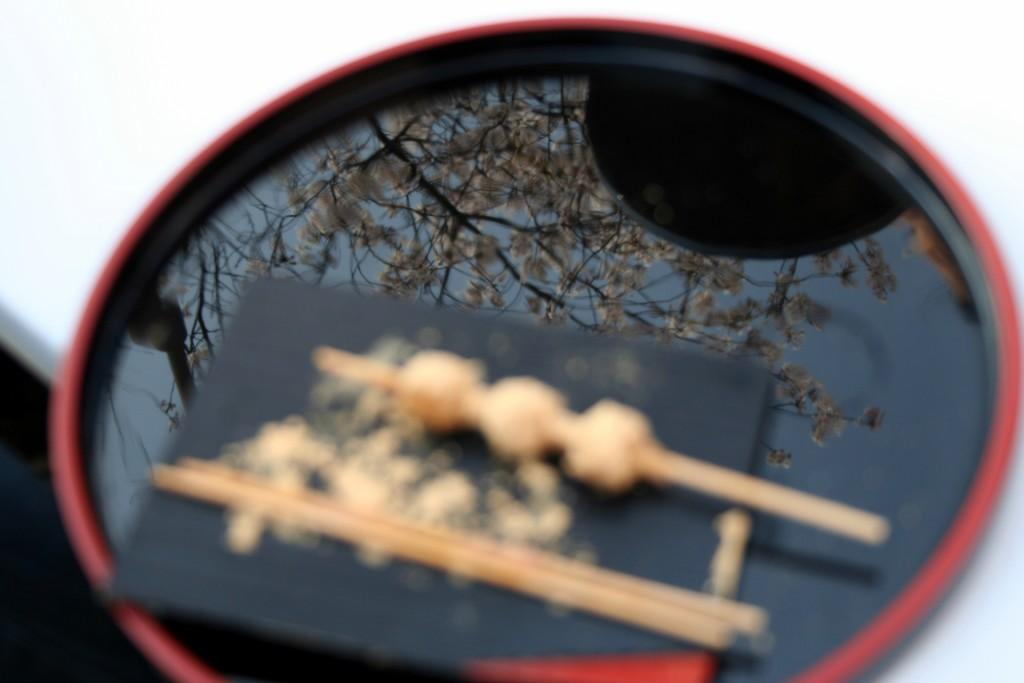What is in the bowl that is visible in the image? There is a bowl filled with water in the image. What is reflected in the water in the image? The tree is shown as a mirror image in the water. What utensils are placed on the bowl in the image? There are two chopsticks placed on the bowl. How many seeds are visible in the image? There are no seeds present in the image. What type of request is being made in the image? There is no request being made in the image. 